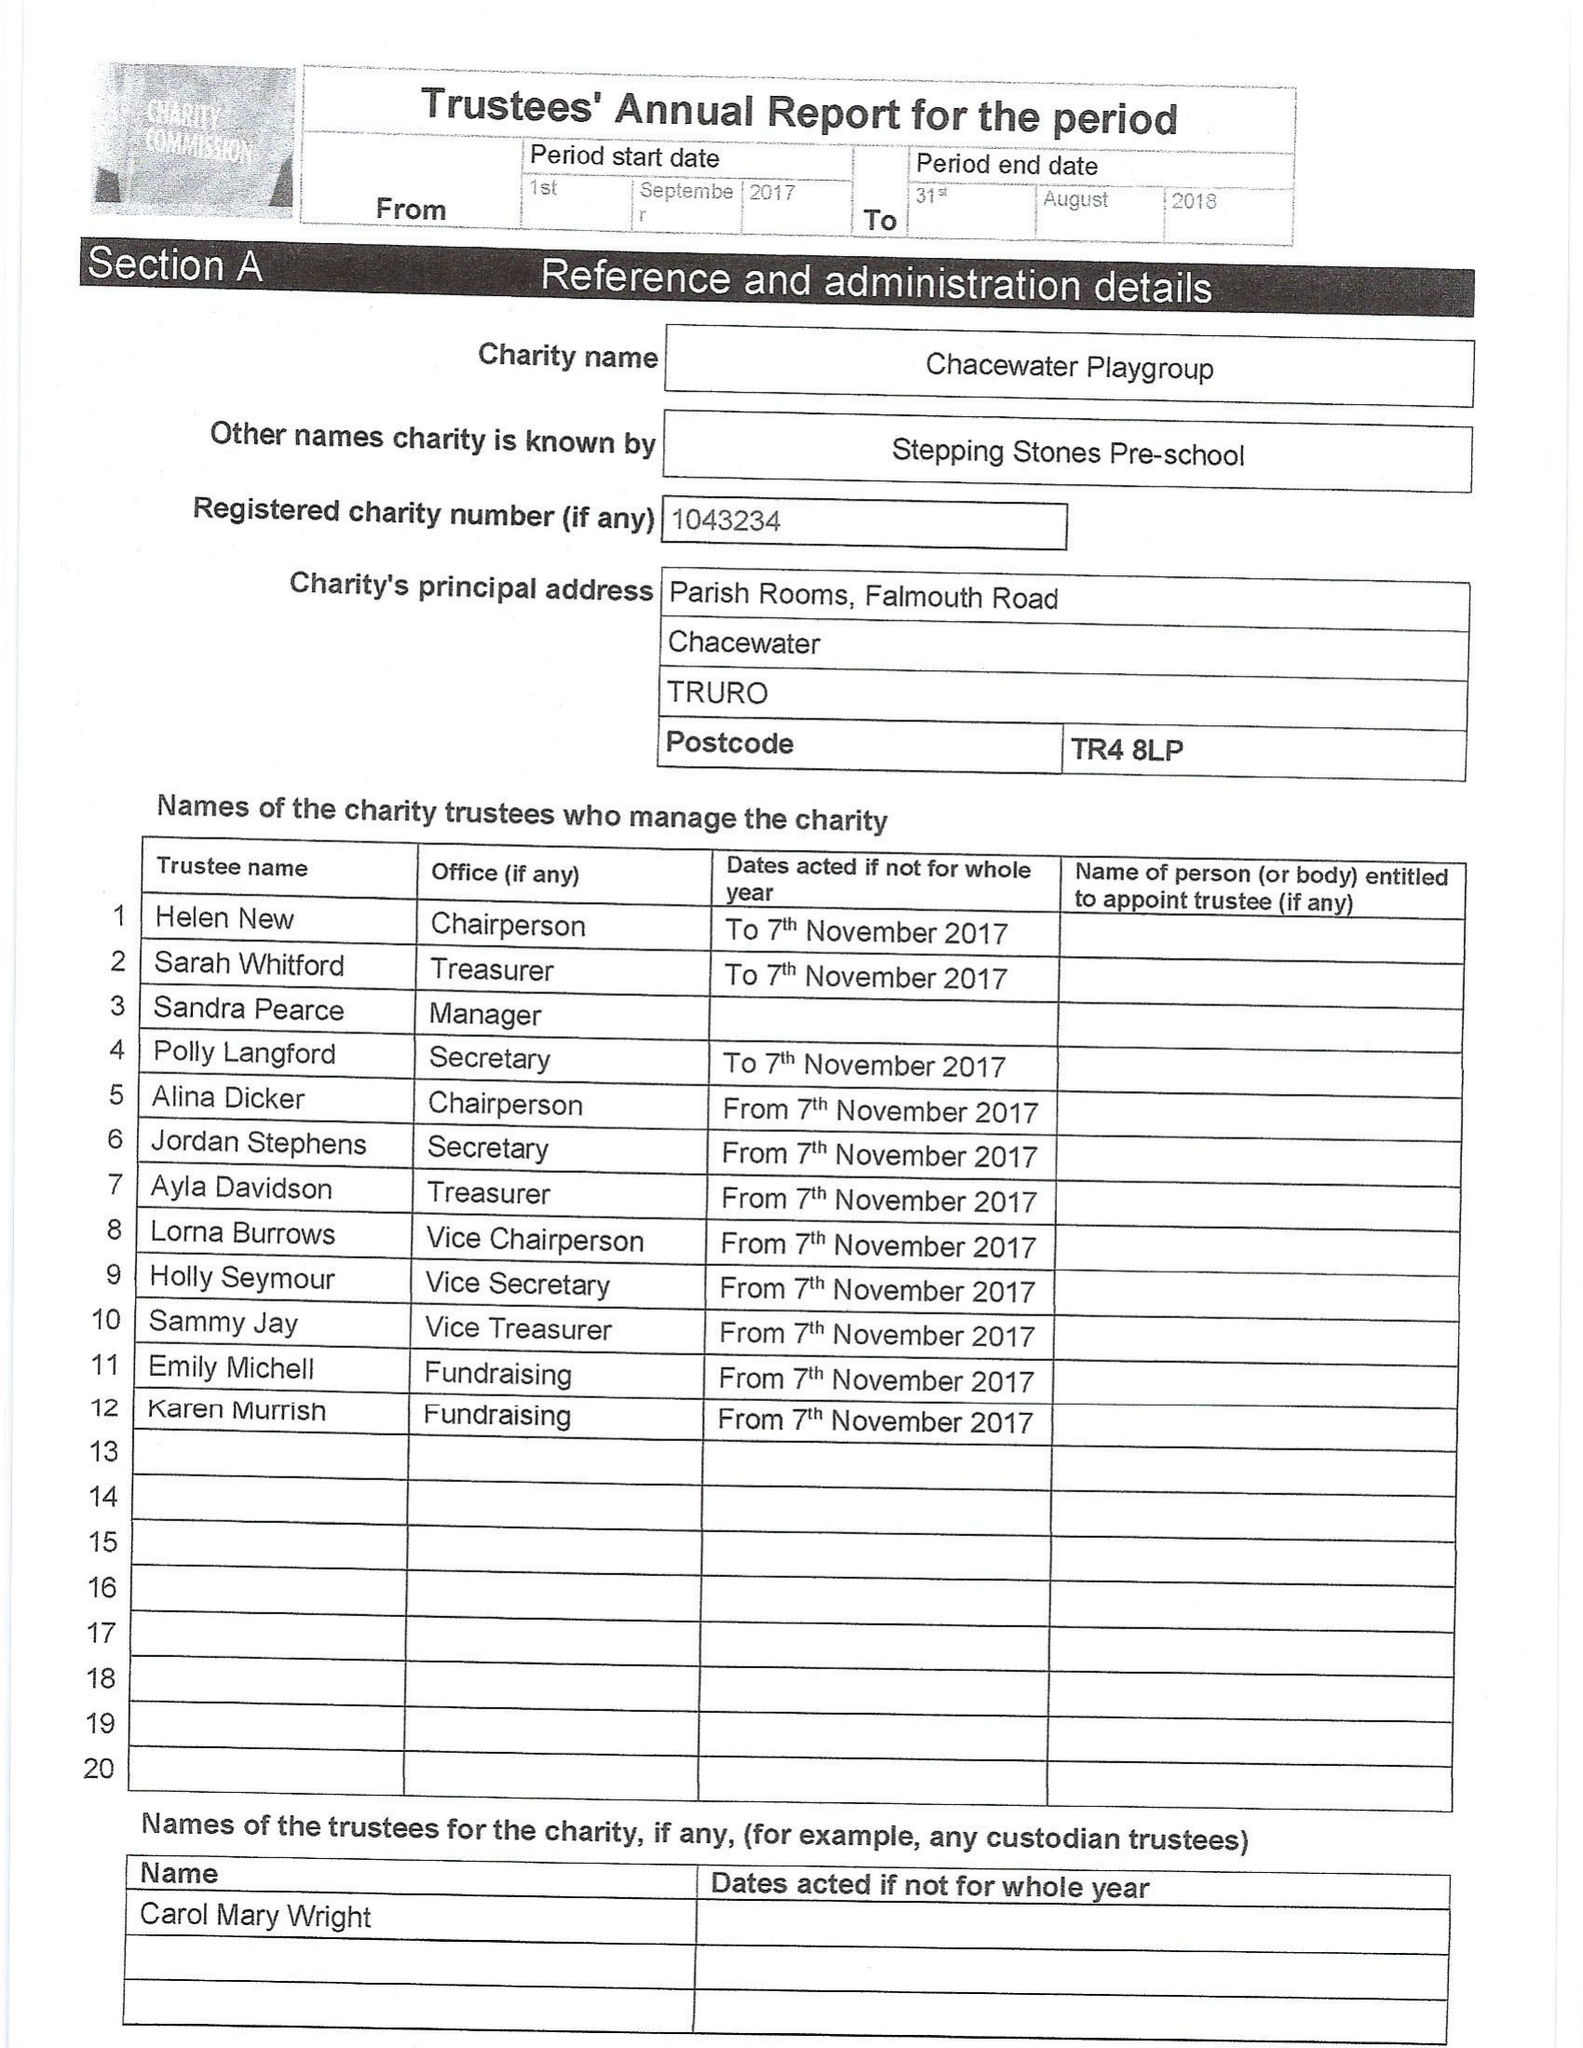What is the value for the income_annually_in_british_pounds?
Answer the question using a single word or phrase. 60416.00 